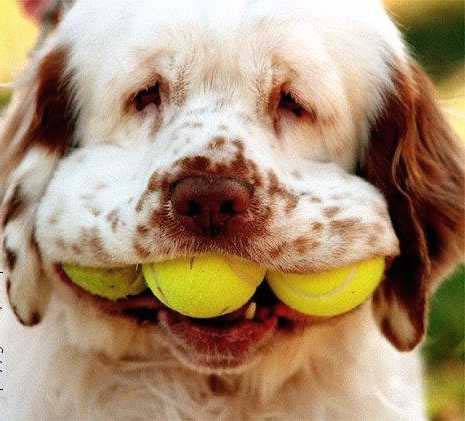Describe the objects in this image and their specific colors. I can see dog in lightgray, maroon, khaki, black, and gray tones, sports ball in khaki, gold, and olive tones, sports ball in khaki, gold, and olive tones, and sports ball in khaki, olive, and maroon tones in this image. 